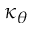Convert formula to latex. <formula><loc_0><loc_0><loc_500><loc_500>\kappa _ { \theta }</formula> 